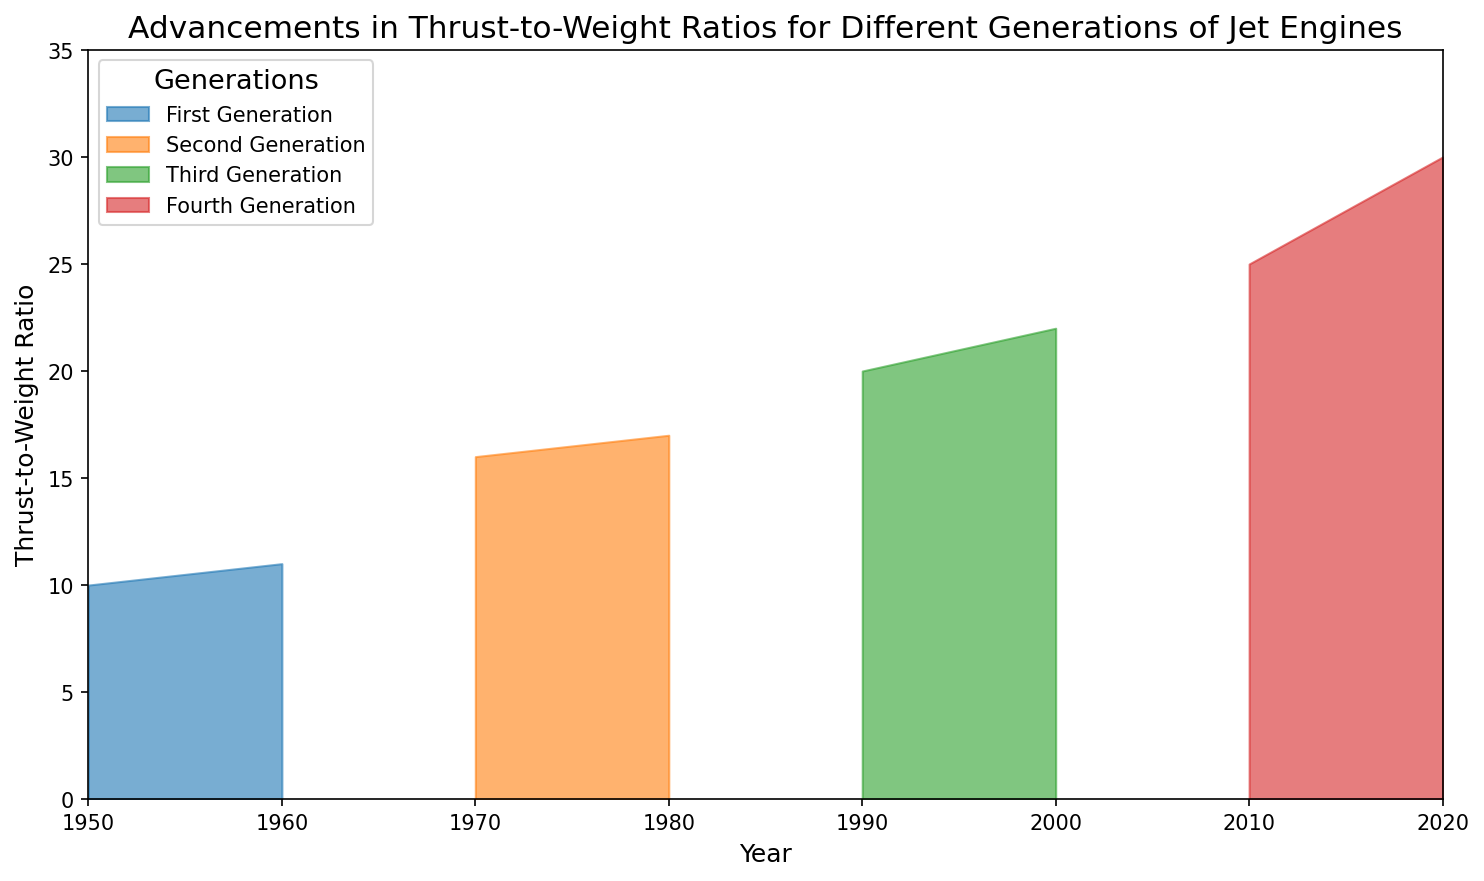What's the general trend in thrust-to-weight ratio for each generation over time? The figure shows that for each generation, the thrust-to-weight ratio increases over time. From 1950 to 1960, the first generation increased from 10 to 11. The second generation grew from 16 in 1970 to 17 in 1980. The third generation saw an increase from 20 in 1990 to 22 in 2000. Finally, the fourth generation had the most significant increase from 25 in 2010 to 30 in 2020.
Answer: The thrust-to-weight ratio increases over time for each generation Which generation had the highest increase in thrust-to-weight ratio between its earliest and latest year? The figure shows that the fourth generation had an increase from 25 in 2010 to 30 in 2020, which is a total increase of 5. This is the highest increase in thrust-to-weight ratio among all generations as the incremental changes in previous generations are either 1 or 2.
Answer: Fourth generation How does the thrust-to-weight ratio of the second generation in 1970 compare to the first generation in 1960? According to the figure, the thrust-to-weight ratio of the second generation in 1970 is 16, while the first generation in 1960 has a thrust-to-weight ratio of 11. Therefore, the second generation in 1970 has a higher thrust-to-weight ratio compared to the first generation in 1960 by 5 units.
Answer: The second generation in 1970 is 5 units higher What's the cumulative thrust-to-weight ratio for all generations in the year 2000? The figure shows the thrust-to-weight ratio for the third generation in the year 2000 is 22. There is no data for other generations in 2000. Hence, the cumulative thrust-to-weight ratio for all generations in 2000 would be the same as the third generation, 22.
Answer: 22 Between which generations did the thrust-to-weight ratio see the most significant increase over the 40-year span depicted? From the figure, observe that between 1950 (first generation) and 1990 (third generation), the thrust-to-weight ratio increased from 10 to 20, a total increase of 10. This is the most significant increase among the decades shown.
Answer: From first to third generation Which generation showed the least progress in its thrust-to-weight ratio across the two decades depicted? Referencing the figure, the first generation from 1950 to 1960 increased from 10 to 11, showing the least progress with only a 1-unit increase.
Answer: First generation In terms of thrust-to-weight ratio, which year had the biggest visual separation between two generations? Reviewing the figure, the year 2020 shows the largest visual separation between the two generations (third and fourth) with values of 22 and 30 respectively, indicating an 8-unit difference.
Answer: 2020 If you average the thrust-to-weight ratios of the last year reported for each generation, what is the result? The last years for each generation are: 1960 (first generation, 11), 1980 (second generation, 17), 2000 (third generation, 22), 2020 (fourth generation, 30). The average is calculated as (11 + 17 + 22 + 30) / 4 = 20.
Answer: 20 How does the thrust-to-weight ratio's improvement rate compare from third to fourth generation versus from first to second generation? The improvement from the third to the fourth generation (20 to 30) is a 10-unit increase over 30 years (1990 to 2020). For the first to second generation (10 to 16), it’s a 6-unit increase over 20 years (1950 to 1970). Thus, per decade, third to fourth generation increased by 3.33 units, while first to second increased by 3 units per decade. Thus, the improvement rate is slightly higher from third to fourth generation.
Answer: Higher from third to fourth generation 